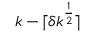<formula> <loc_0><loc_0><loc_500><loc_500>k - \lceil \delta k ^ { \frac { 1 } { 2 } } \rceil</formula> 